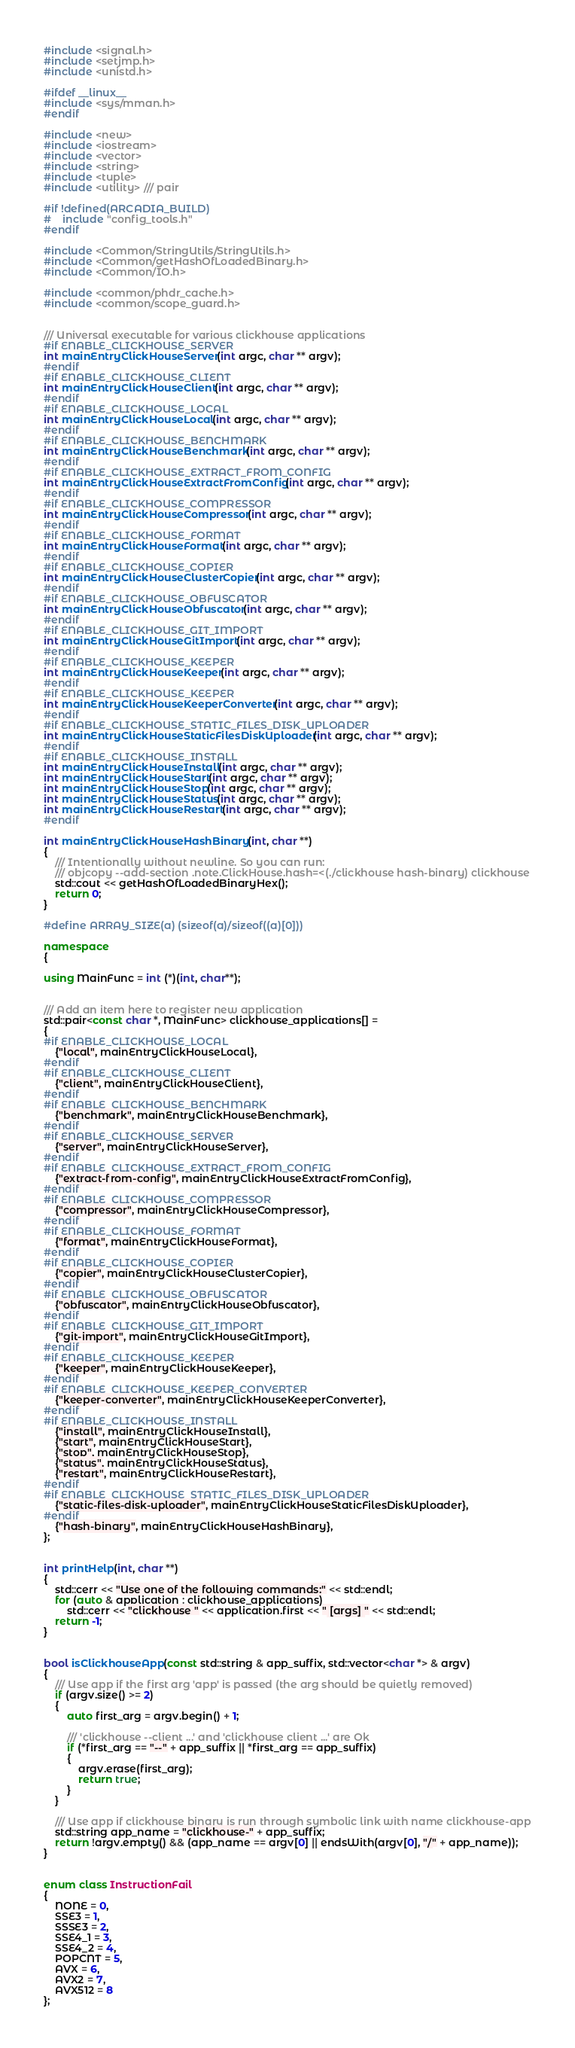Convert code to text. <code><loc_0><loc_0><loc_500><loc_500><_C++_>#include <signal.h>
#include <setjmp.h>
#include <unistd.h>

#ifdef __linux__
#include <sys/mman.h>
#endif

#include <new>
#include <iostream>
#include <vector>
#include <string>
#include <tuple>
#include <utility> /// pair

#if !defined(ARCADIA_BUILD)
#    include "config_tools.h"
#endif

#include <Common/StringUtils/StringUtils.h>
#include <Common/getHashOfLoadedBinary.h>
#include <Common/IO.h>

#include <common/phdr_cache.h>
#include <common/scope_guard.h>


/// Universal executable for various clickhouse applications
#if ENABLE_CLICKHOUSE_SERVER
int mainEntryClickHouseServer(int argc, char ** argv);
#endif
#if ENABLE_CLICKHOUSE_CLIENT
int mainEntryClickHouseClient(int argc, char ** argv);
#endif
#if ENABLE_CLICKHOUSE_LOCAL
int mainEntryClickHouseLocal(int argc, char ** argv);
#endif
#if ENABLE_CLICKHOUSE_BENCHMARK
int mainEntryClickHouseBenchmark(int argc, char ** argv);
#endif
#if ENABLE_CLICKHOUSE_EXTRACT_FROM_CONFIG
int mainEntryClickHouseExtractFromConfig(int argc, char ** argv);
#endif
#if ENABLE_CLICKHOUSE_COMPRESSOR
int mainEntryClickHouseCompressor(int argc, char ** argv);
#endif
#if ENABLE_CLICKHOUSE_FORMAT
int mainEntryClickHouseFormat(int argc, char ** argv);
#endif
#if ENABLE_CLICKHOUSE_COPIER
int mainEntryClickHouseClusterCopier(int argc, char ** argv);
#endif
#if ENABLE_CLICKHOUSE_OBFUSCATOR
int mainEntryClickHouseObfuscator(int argc, char ** argv);
#endif
#if ENABLE_CLICKHOUSE_GIT_IMPORT
int mainEntryClickHouseGitImport(int argc, char ** argv);
#endif
#if ENABLE_CLICKHOUSE_KEEPER
int mainEntryClickHouseKeeper(int argc, char ** argv);
#endif
#if ENABLE_CLICKHOUSE_KEEPER
int mainEntryClickHouseKeeperConverter(int argc, char ** argv);
#endif
#if ENABLE_CLICKHOUSE_STATIC_FILES_DISK_UPLOADER
int mainEntryClickHouseStaticFilesDiskUploader(int argc, char ** argv);
#endif
#if ENABLE_CLICKHOUSE_INSTALL
int mainEntryClickHouseInstall(int argc, char ** argv);
int mainEntryClickHouseStart(int argc, char ** argv);
int mainEntryClickHouseStop(int argc, char ** argv);
int mainEntryClickHouseStatus(int argc, char ** argv);
int mainEntryClickHouseRestart(int argc, char ** argv);
#endif

int mainEntryClickHouseHashBinary(int, char **)
{
    /// Intentionally without newline. So you can run:
    /// objcopy --add-section .note.ClickHouse.hash=<(./clickhouse hash-binary) clickhouse
    std::cout << getHashOfLoadedBinaryHex();
    return 0;
}

#define ARRAY_SIZE(a) (sizeof(a)/sizeof((a)[0]))

namespace
{

using MainFunc = int (*)(int, char**);


/// Add an item here to register new application
std::pair<const char *, MainFunc> clickhouse_applications[] =
{
#if ENABLE_CLICKHOUSE_LOCAL
    {"local", mainEntryClickHouseLocal},
#endif
#if ENABLE_CLICKHOUSE_CLIENT
    {"client", mainEntryClickHouseClient},
#endif
#if ENABLE_CLICKHOUSE_BENCHMARK
    {"benchmark", mainEntryClickHouseBenchmark},
#endif
#if ENABLE_CLICKHOUSE_SERVER
    {"server", mainEntryClickHouseServer},
#endif
#if ENABLE_CLICKHOUSE_EXTRACT_FROM_CONFIG
    {"extract-from-config", mainEntryClickHouseExtractFromConfig},
#endif
#if ENABLE_CLICKHOUSE_COMPRESSOR
    {"compressor", mainEntryClickHouseCompressor},
#endif
#if ENABLE_CLICKHOUSE_FORMAT
    {"format", mainEntryClickHouseFormat},
#endif
#if ENABLE_CLICKHOUSE_COPIER
    {"copier", mainEntryClickHouseClusterCopier},
#endif
#if ENABLE_CLICKHOUSE_OBFUSCATOR
    {"obfuscator", mainEntryClickHouseObfuscator},
#endif
#if ENABLE_CLICKHOUSE_GIT_IMPORT
    {"git-import", mainEntryClickHouseGitImport},
#endif
#if ENABLE_CLICKHOUSE_KEEPER
    {"keeper", mainEntryClickHouseKeeper},
#endif
#if ENABLE_CLICKHOUSE_KEEPER_CONVERTER
    {"keeper-converter", mainEntryClickHouseKeeperConverter},
#endif
#if ENABLE_CLICKHOUSE_INSTALL
    {"install", mainEntryClickHouseInstall},
    {"start", mainEntryClickHouseStart},
    {"stop", mainEntryClickHouseStop},
    {"status", mainEntryClickHouseStatus},
    {"restart", mainEntryClickHouseRestart},
#endif
#if ENABLE_CLICKHOUSE_STATIC_FILES_DISK_UPLOADER
    {"static-files-disk-uploader", mainEntryClickHouseStaticFilesDiskUploader},
#endif
    {"hash-binary", mainEntryClickHouseHashBinary},
};


int printHelp(int, char **)
{
    std::cerr << "Use one of the following commands:" << std::endl;
    for (auto & application : clickhouse_applications)
        std::cerr << "clickhouse " << application.first << " [args] " << std::endl;
    return -1;
}


bool isClickhouseApp(const std::string & app_suffix, std::vector<char *> & argv)
{
    /// Use app if the first arg 'app' is passed (the arg should be quietly removed)
    if (argv.size() >= 2)
    {
        auto first_arg = argv.begin() + 1;

        /// 'clickhouse --client ...' and 'clickhouse client ...' are Ok
        if (*first_arg == "--" + app_suffix || *first_arg == app_suffix)
        {
            argv.erase(first_arg);
            return true;
        }
    }

    /// Use app if clickhouse binary is run through symbolic link with name clickhouse-app
    std::string app_name = "clickhouse-" + app_suffix;
    return !argv.empty() && (app_name == argv[0] || endsWith(argv[0], "/" + app_name));
}


enum class InstructionFail
{
    NONE = 0,
    SSE3 = 1,
    SSSE3 = 2,
    SSE4_1 = 3,
    SSE4_2 = 4,
    POPCNT = 5,
    AVX = 6,
    AVX2 = 7,
    AVX512 = 8
};
</code> 